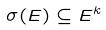Convert formula to latex. <formula><loc_0><loc_0><loc_500><loc_500>\sigma ( E ) \subseteq E ^ { k }</formula> 